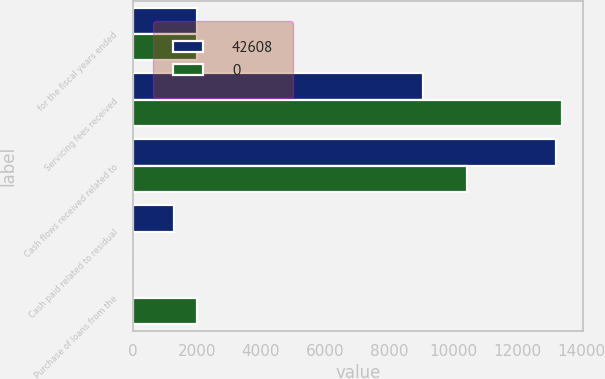Convert chart to OTSL. <chart><loc_0><loc_0><loc_500><loc_500><stacked_bar_chart><ecel><fcel>for the fiscal years ended<fcel>Servicing fees received<fcel>Cash flows received related to<fcel>Cash paid related to residual<fcel>Purchase of loans from the<nl><fcel>42608<fcel>2010<fcel>9078<fcel>13204<fcel>1286<fcel>0<nl><fcel>0<fcel>2008<fcel>13389<fcel>10441<fcel>0<fcel>2008<nl></chart> 